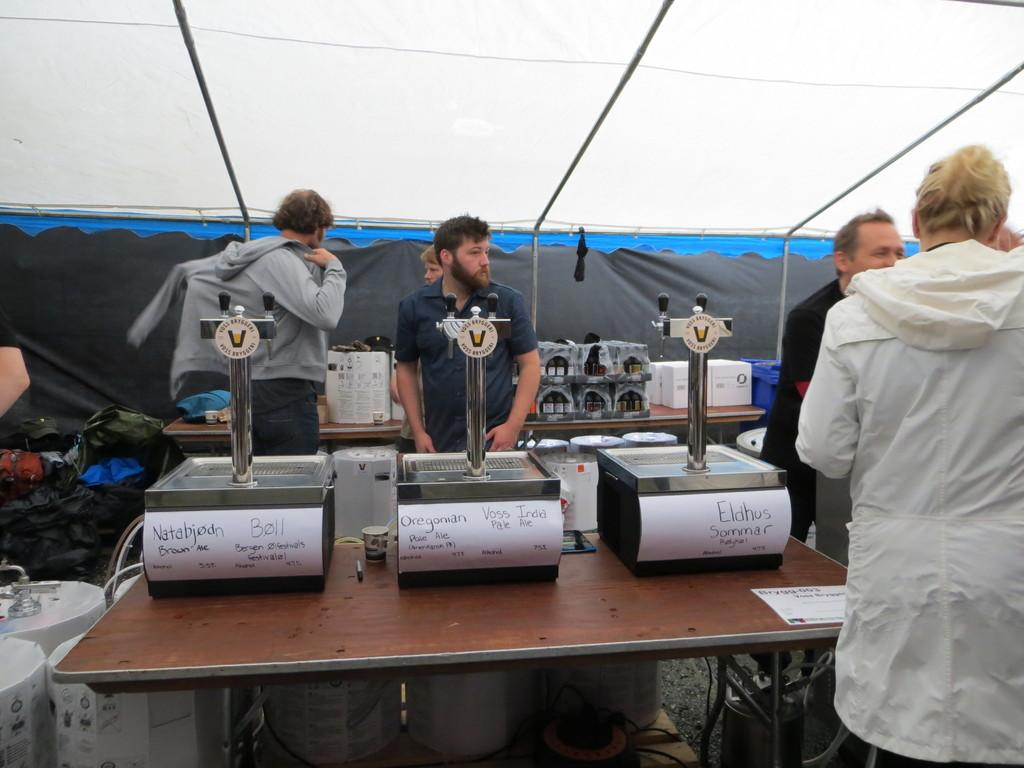Where is the image taken? The image is taken under a tent. What can be seen in the image besides the tent? There are people standing in the image, and there are machines on a table. What else is visible in the background of the image? In the background, there are other machines visible, and there is a carton on a table. What type of authority figure can be seen in the image? There is no authority figure present in the image. What role does coal play in the image? There is no coal present in the image. 